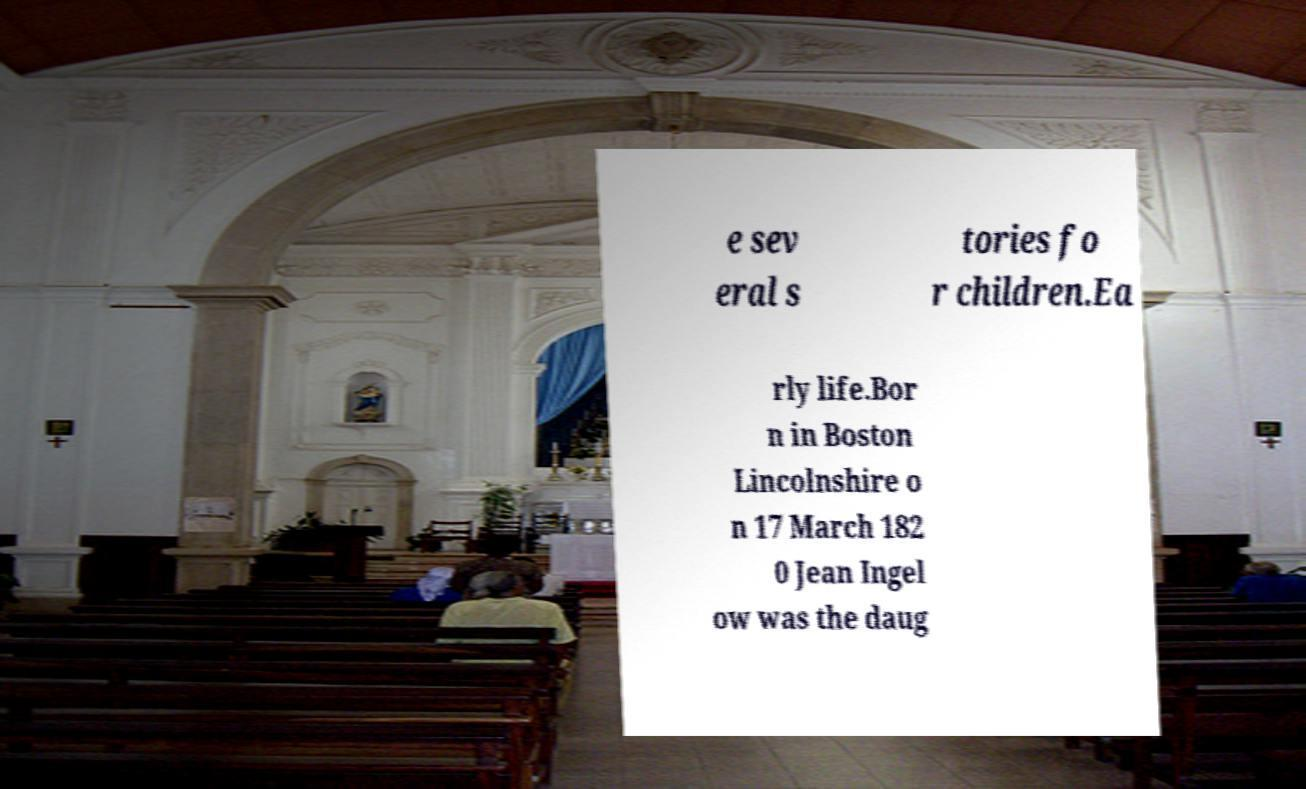For documentation purposes, I need the text within this image transcribed. Could you provide that? e sev eral s tories fo r children.Ea rly life.Bor n in Boston Lincolnshire o n 17 March 182 0 Jean Ingel ow was the daug 